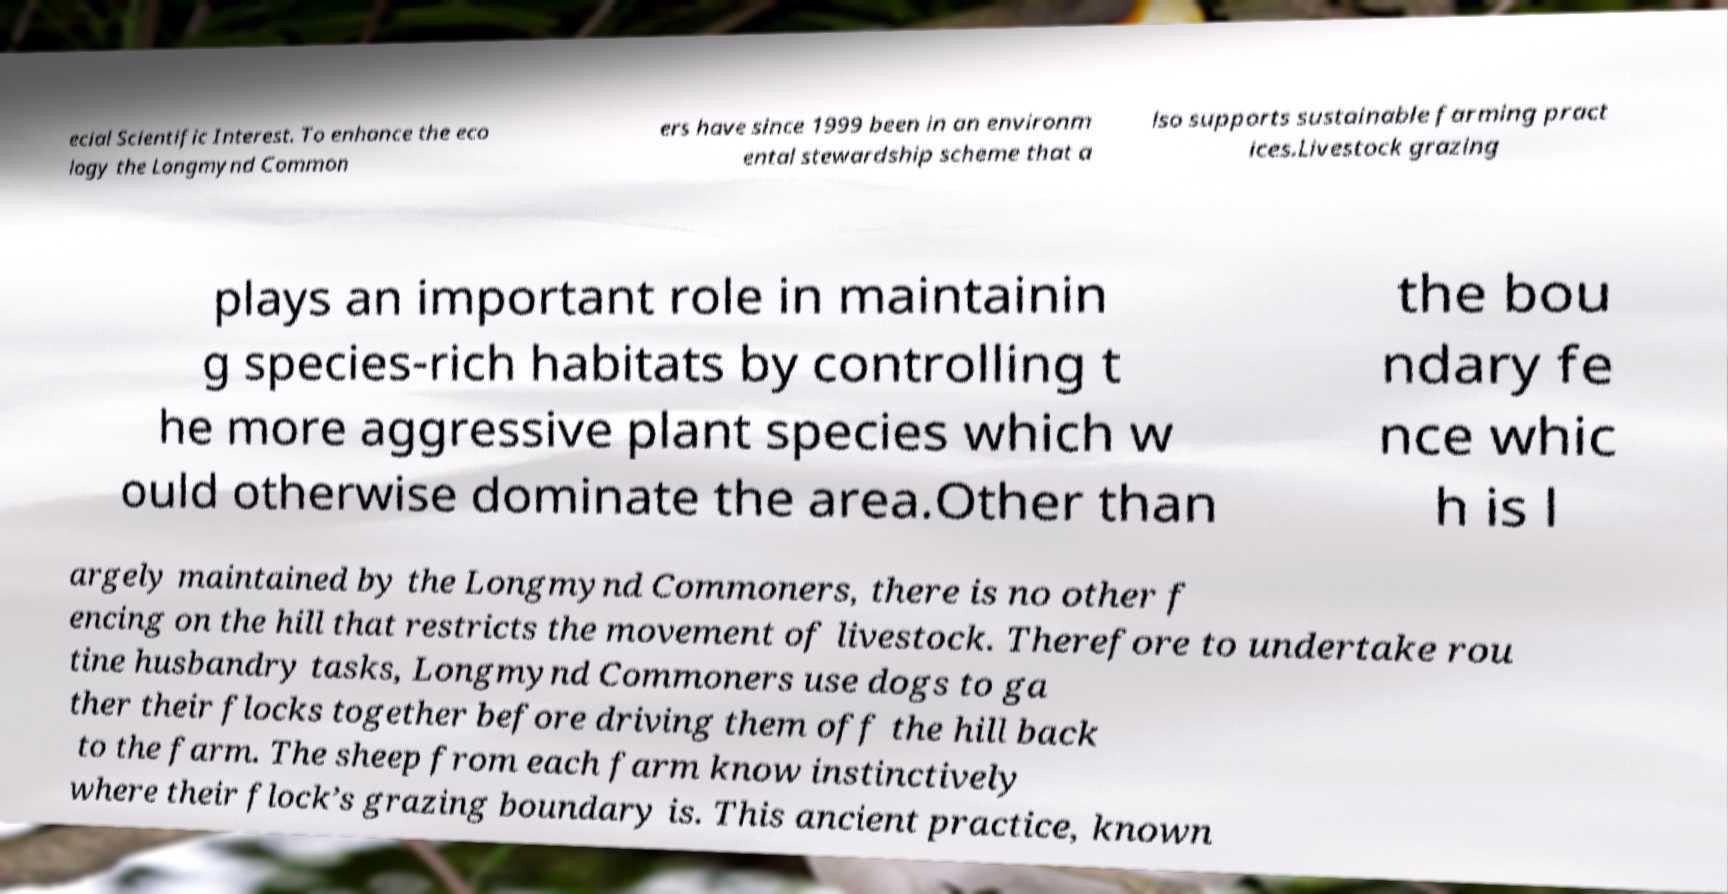Please read and relay the text visible in this image. What does it say? ecial Scientific Interest. To enhance the eco logy the Longmynd Common ers have since 1999 been in an environm ental stewardship scheme that a lso supports sustainable farming pract ices.Livestock grazing plays an important role in maintainin g species-rich habitats by controlling t he more aggressive plant species which w ould otherwise dominate the area.Other than the bou ndary fe nce whic h is l argely maintained by the Longmynd Commoners, there is no other f encing on the hill that restricts the movement of livestock. Therefore to undertake rou tine husbandry tasks, Longmynd Commoners use dogs to ga ther their flocks together before driving them off the hill back to the farm. The sheep from each farm know instinctively where their flock’s grazing boundary is. This ancient practice, known 